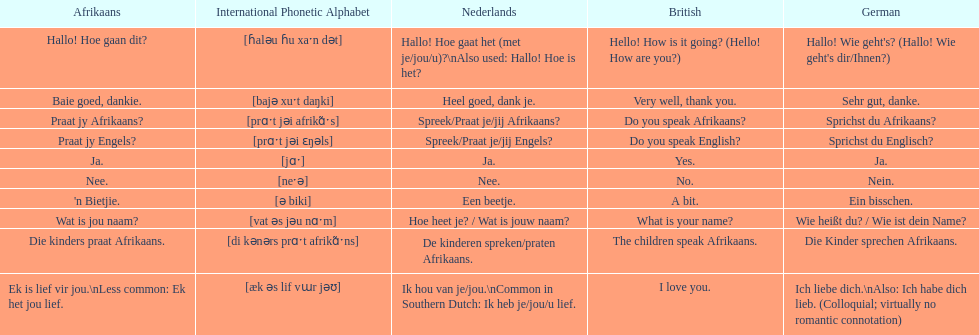How do you say 'yes' in afrikaans? Ja. 